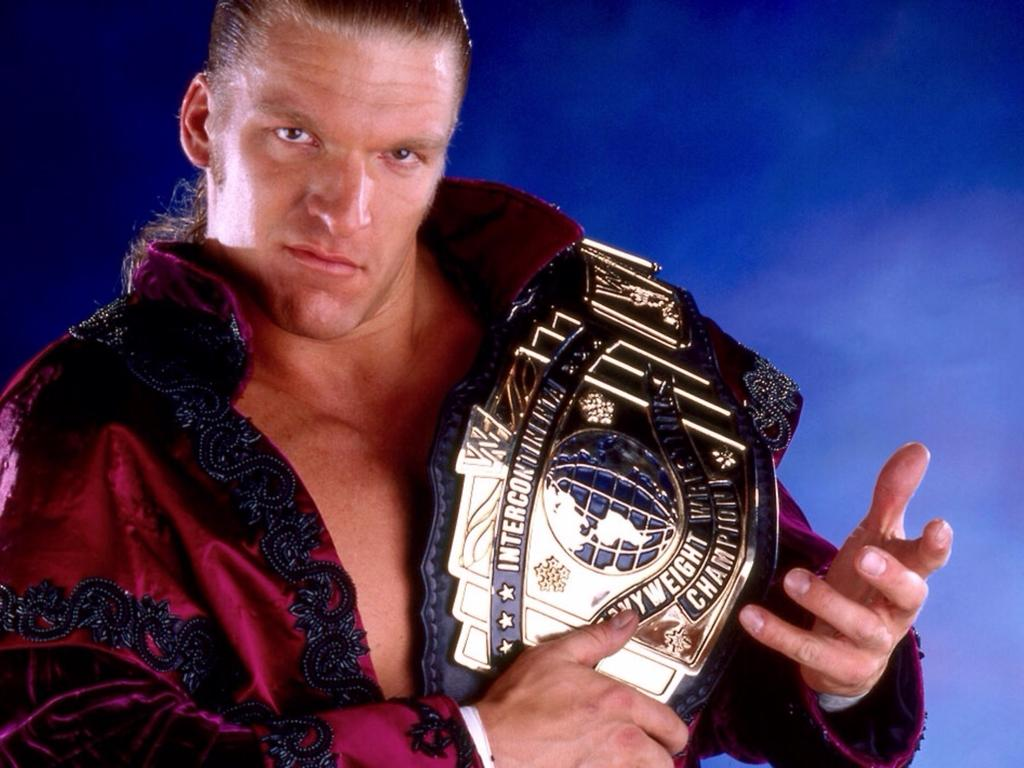<image>
Provide a brief description of the given image. a man is holding a heavy weight champion belt on his shoulder 